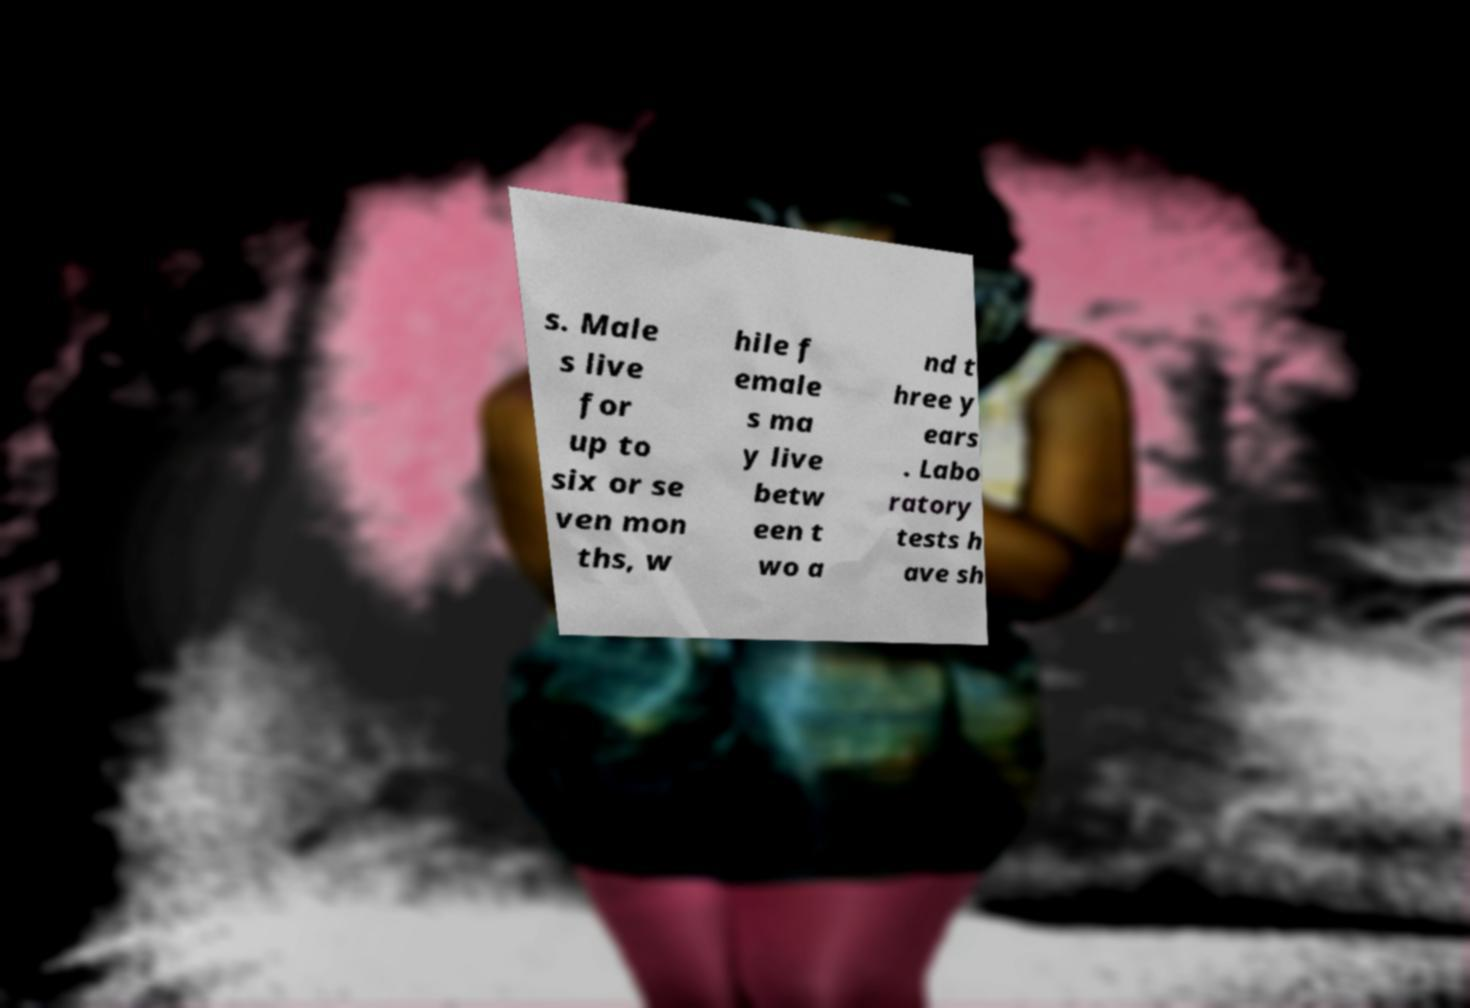Can you accurately transcribe the text from the provided image for me? s. Male s live for up to six or se ven mon ths, w hile f emale s ma y live betw een t wo a nd t hree y ears . Labo ratory tests h ave sh 